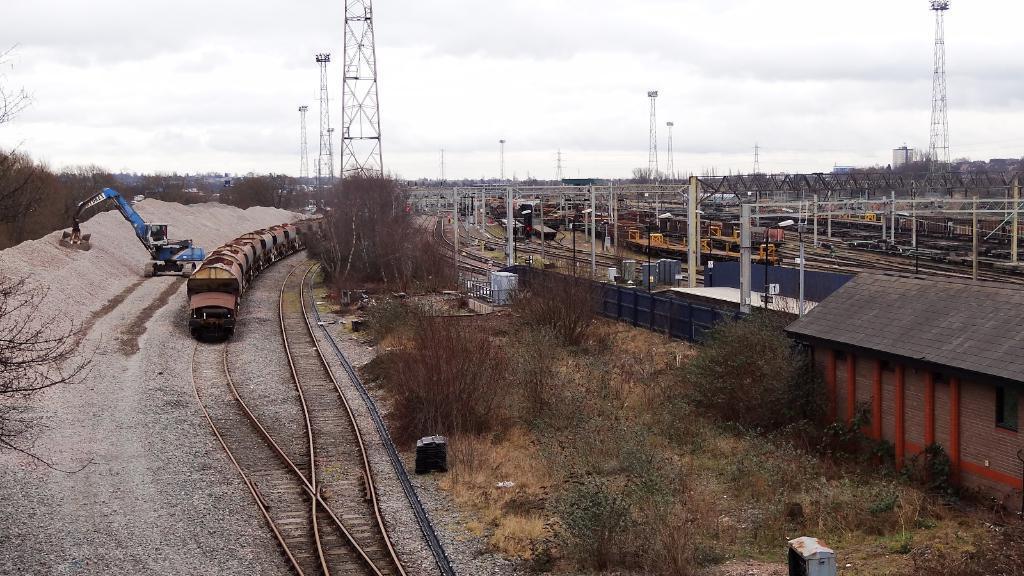How would you summarize this image in a sentence or two? There is a train on the track and there are few other trains on the tracks in the right corner and there are few miles above it and there are trees in the left corner. 